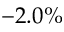<formula> <loc_0><loc_0><loc_500><loc_500>- 2 . 0 \%</formula> 